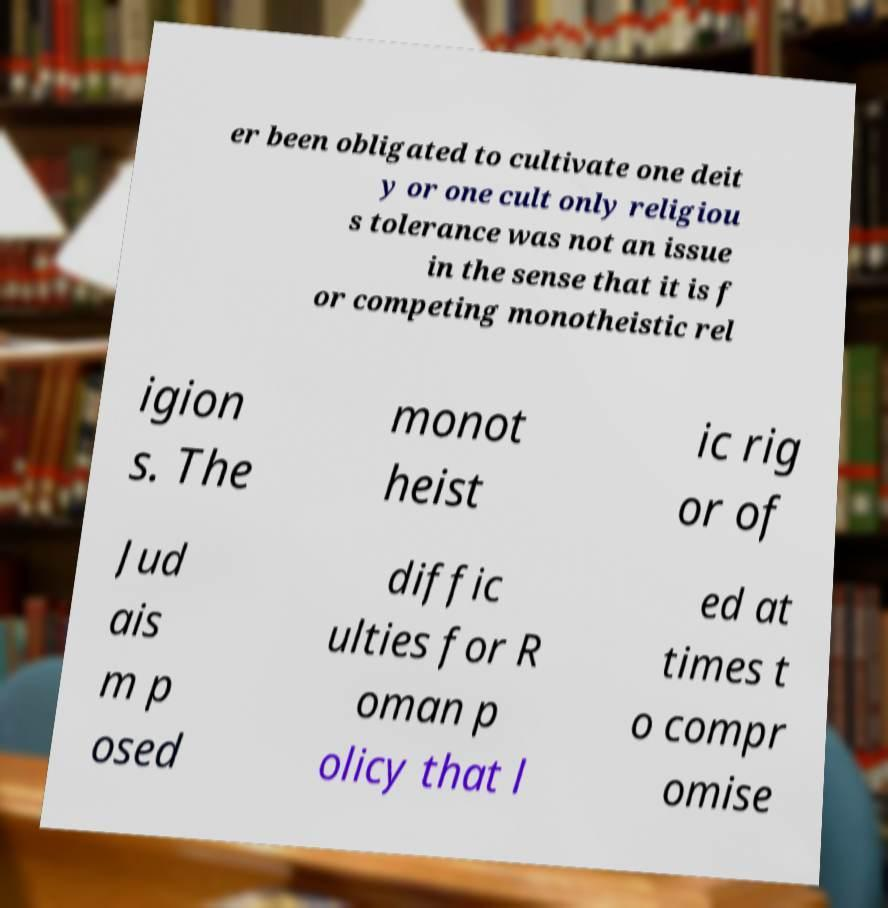Please read and relay the text visible in this image. What does it say? er been obligated to cultivate one deit y or one cult only religiou s tolerance was not an issue in the sense that it is f or competing monotheistic rel igion s. The monot heist ic rig or of Jud ais m p osed diffic ulties for R oman p olicy that l ed at times t o compr omise 